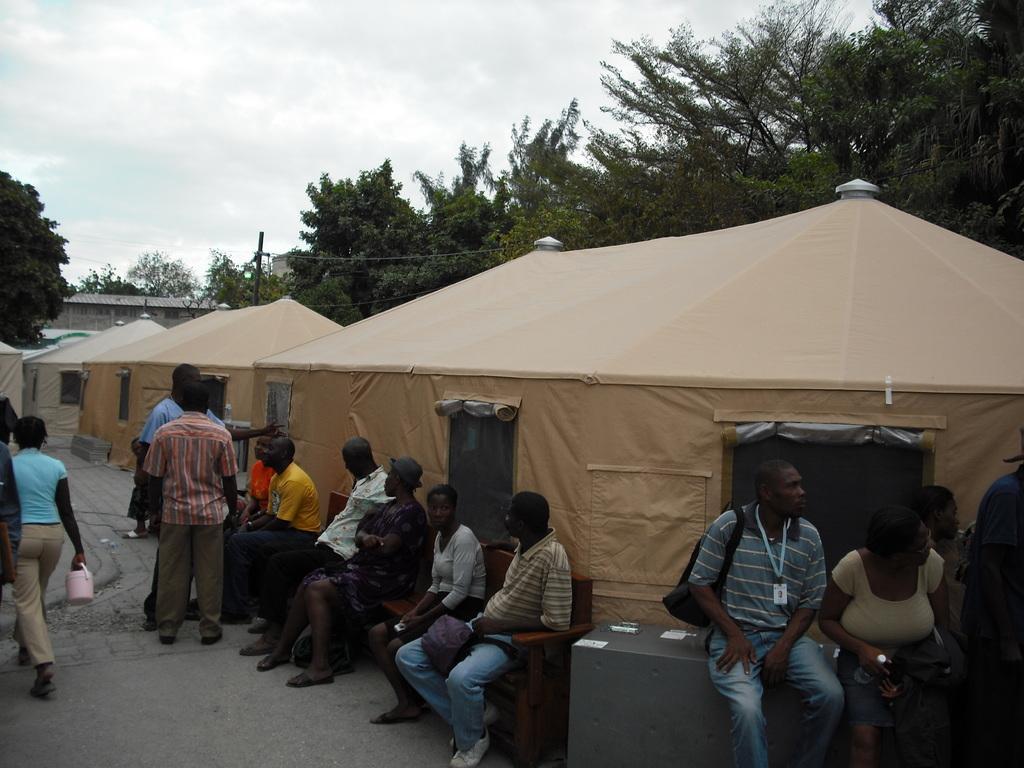How would you summarize this image in a sentence or two? There are some persons sitting on the chairs at the bottom of this image, and there are some persons sitting on a table at the bottom right corner of this image, and there are some persons standing at the bottom left side of this image. There are some tents and trees in the background. There is a sky at the top of this image. 